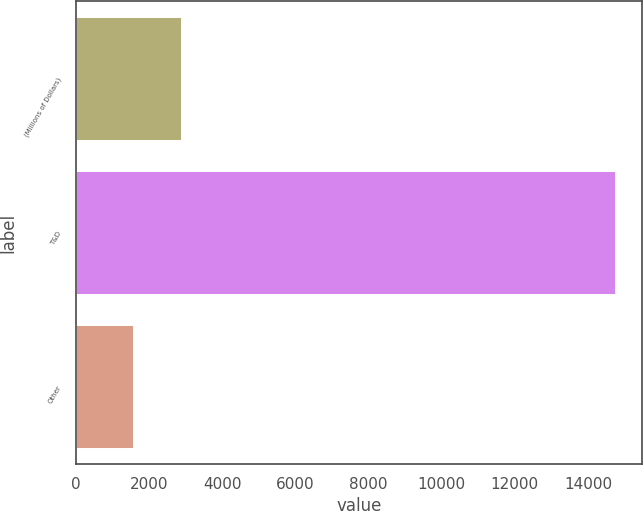<chart> <loc_0><loc_0><loc_500><loc_500><bar_chart><fcel>(Millions of Dollars)<fcel>T&D<fcel>Other<nl><fcel>2882.7<fcel>14742<fcel>1565<nl></chart> 